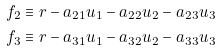Convert formula to latex. <formula><loc_0><loc_0><loc_500><loc_500>f _ { 2 } & \equiv r - a _ { 2 1 } u _ { 1 } - a _ { 2 2 } u _ { 2 } - a _ { 2 3 } u _ { 3 } \\ f _ { 3 } & \equiv r - a _ { 3 1 } u _ { 1 } - a _ { 3 2 } u _ { 2 } - a _ { 3 3 } u _ { 3 }</formula> 